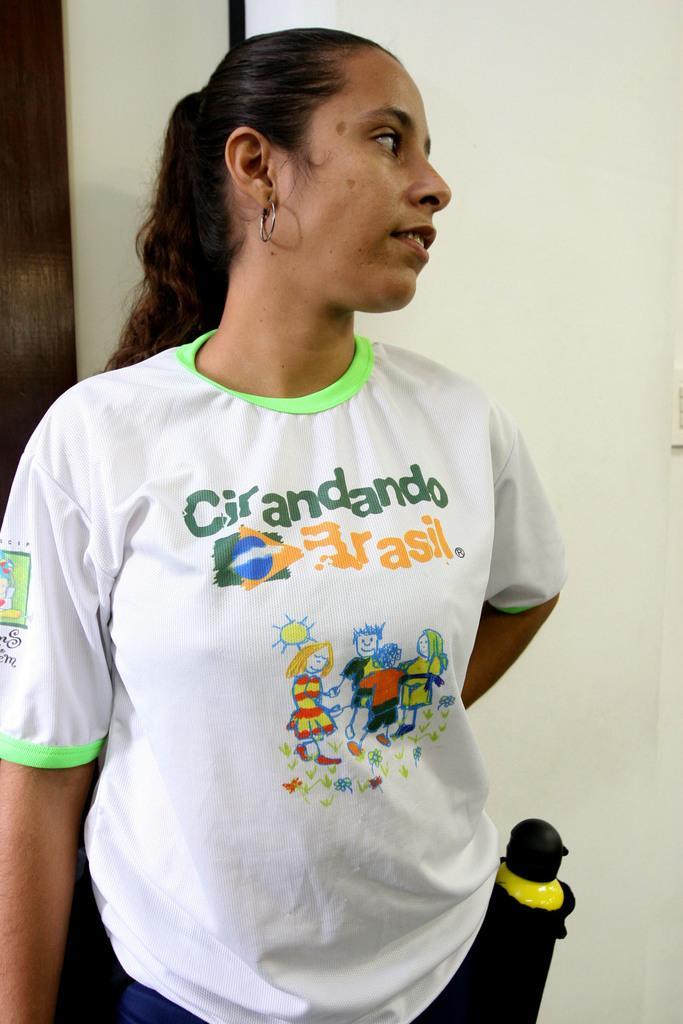Please provide a concise description of this image. Background portion of the picture is white and brown in color. In this picture we can see a woman wearing a t-shirt. On the right side of the picture we can see an object. 